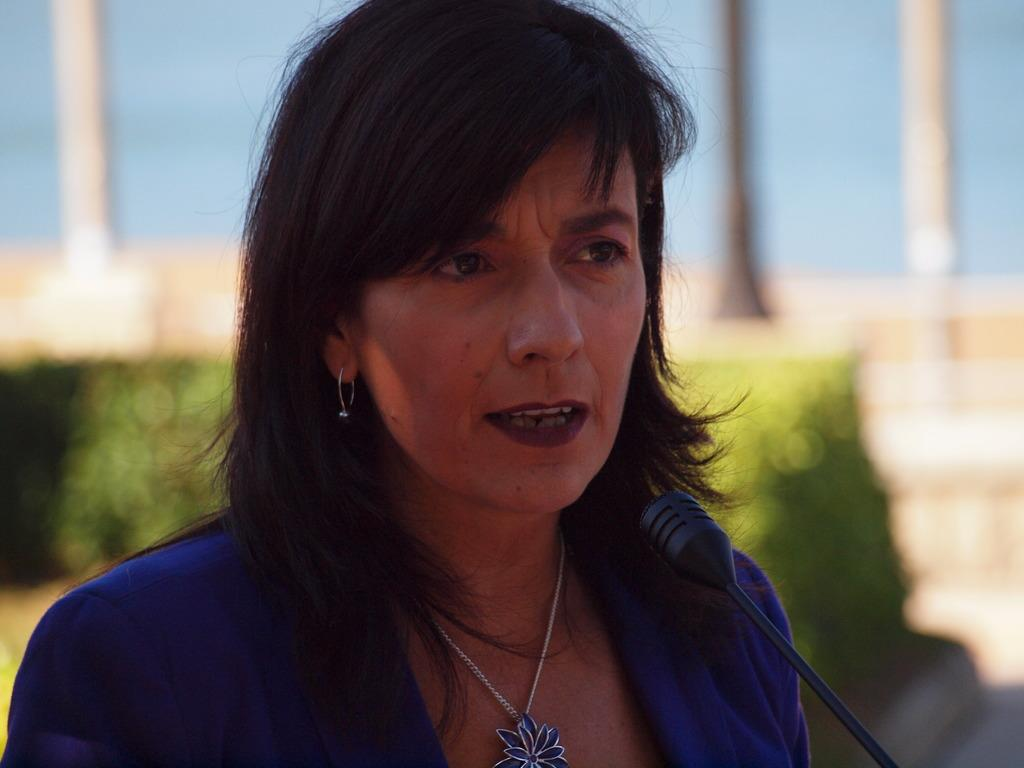Who is the main subject in the image? There is a woman in the image. What object is in front of the woman? There is a microphone in front of the woman. What can be seen behind the woman? There are plants behind the woman. What is visible at the top of the image? The sky is visible at the top of the image. How would you describe the background of the image? The background of the image appears blurry. What type of argument can be seen taking place between the woman and the bit in the image? There is no argument or bit present in the image. 